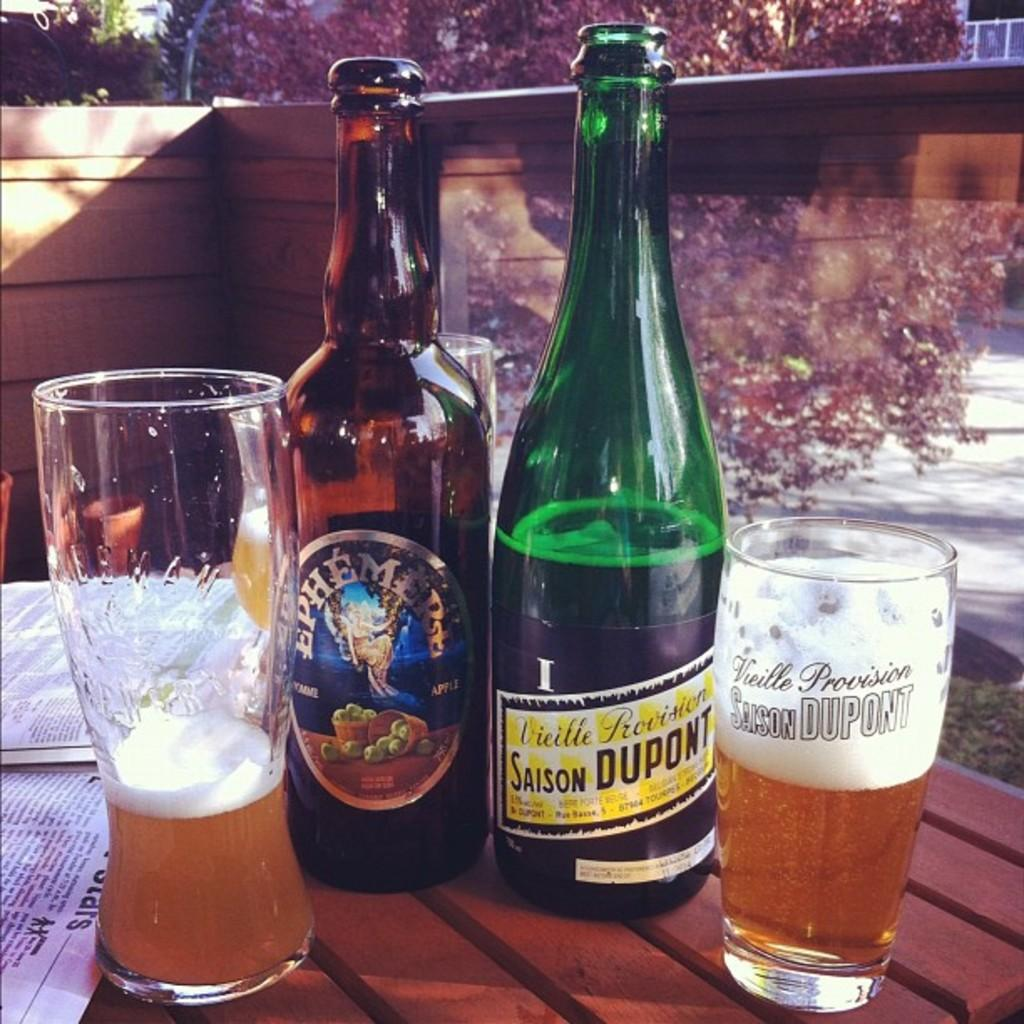What piece of furniture is present in the image? There is a table in the image. What items are placed on the table? There are two bottles, two glasses, and a book on the table. What can be seen in the background of the image? There are trees visible in the background of the image. What type of pies are being served by the authority figure in the image? There are no pies or authority figures present in the image. 